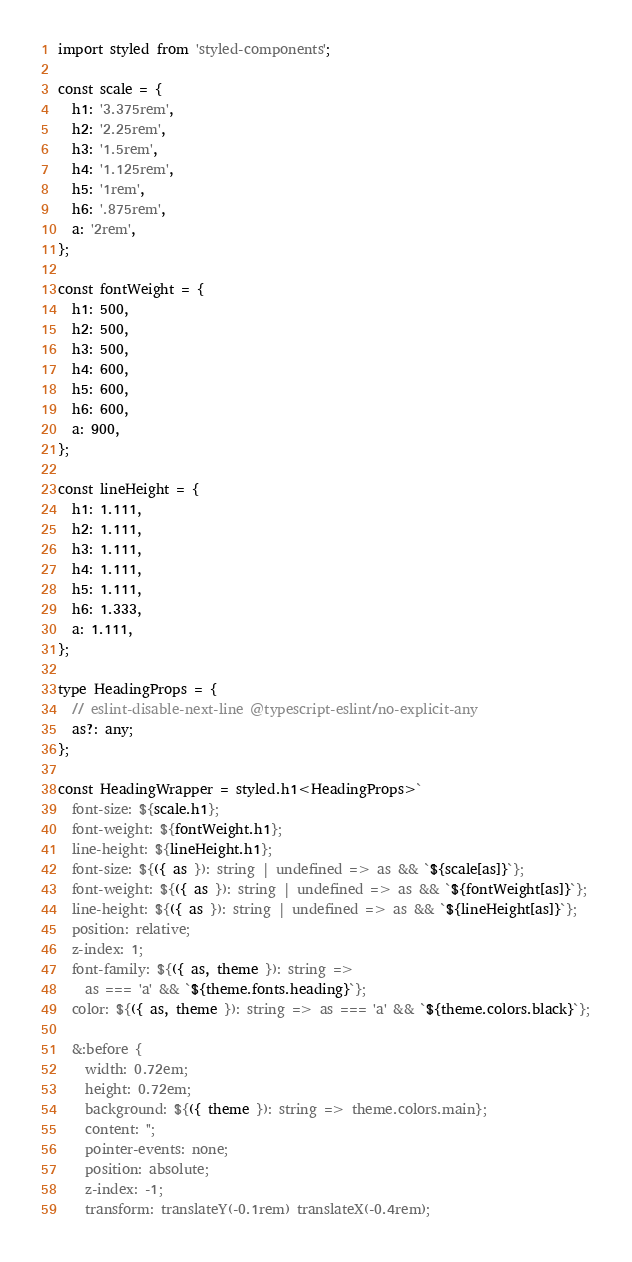<code> <loc_0><loc_0><loc_500><loc_500><_TypeScript_>import styled from 'styled-components';

const scale = {
  h1: '3.375rem',
  h2: '2.25rem',
  h3: '1.5rem',
  h4: '1.125rem',
  h5: '1rem',
  h6: '.875rem',
  a: '2rem',
};

const fontWeight = {
  h1: 500,
  h2: 500,
  h3: 500,
  h4: 600,
  h5: 600,
  h6: 600,
  a: 900,
};

const lineHeight = {
  h1: 1.111,
  h2: 1.111,
  h3: 1.111,
  h4: 1.111,
  h5: 1.111,
  h6: 1.333,
  a: 1.111,
};

type HeadingProps = {
  // eslint-disable-next-line @typescript-eslint/no-explicit-any
  as?: any;
};

const HeadingWrapper = styled.h1<HeadingProps>`
  font-size: ${scale.h1};
  font-weight: ${fontWeight.h1};
  line-height: ${lineHeight.h1};
  font-size: ${({ as }): string | undefined => as && `${scale[as]}`};
  font-weight: ${({ as }): string | undefined => as && `${fontWeight[as]}`};
  line-height: ${({ as }): string | undefined => as && `${lineHeight[as]}`};
  position: relative;
  z-index: 1;
  font-family: ${({ as, theme }): string =>
    as === 'a' && `${theme.fonts.heading}`};
  color: ${({ as, theme }): string => as === 'a' && `${theme.colors.black}`};

  &:before {
    width: 0.72em;
    height: 0.72em;
    background: ${({ theme }): string => theme.colors.main};
    content: '';
    pointer-events: none;
    position: absolute;
    z-index: -1;
    transform: translateY(-0.1rem) translateX(-0.4rem);</code> 